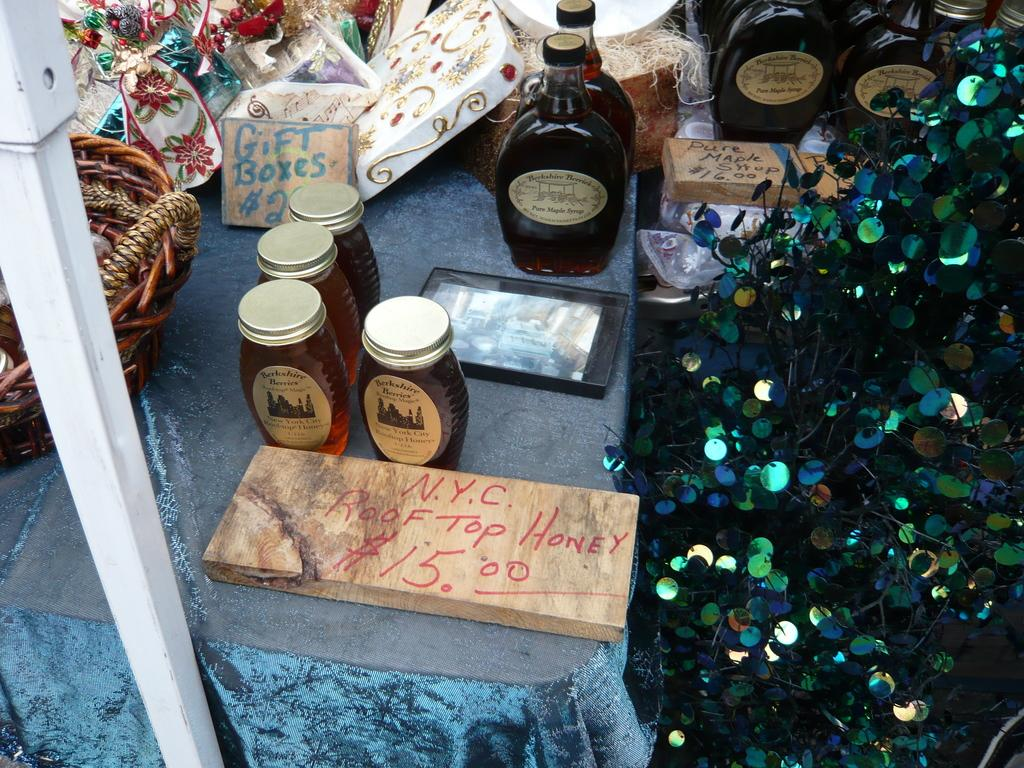What piece of furniture is present in the image? There is a table in the image. What items can be seen on the table? There are bottles and boxes on the table. What type of plant is near the table? There is a fancy plant near the table. What hobbies does the fancy plant enjoy in the image? The fancy plant does not have hobbies, as it is a non-living object. 